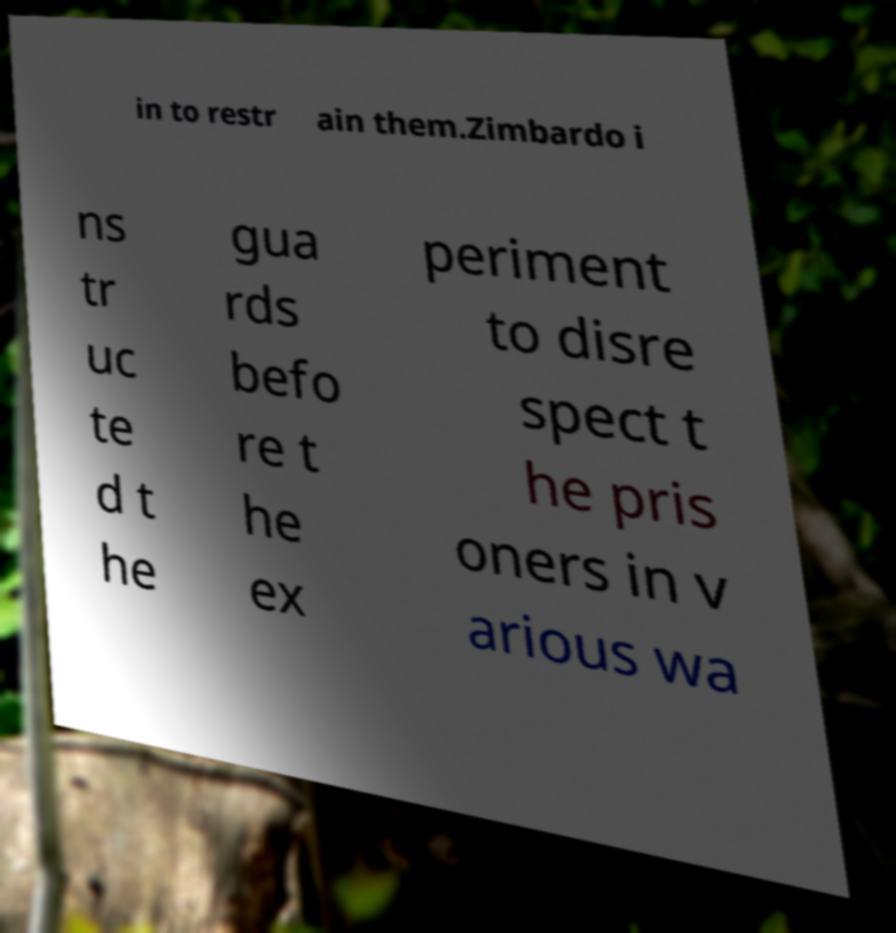For documentation purposes, I need the text within this image transcribed. Could you provide that? in to restr ain them.Zimbardo i ns tr uc te d t he gua rds befo re t he ex periment to disre spect t he pris oners in v arious wa 